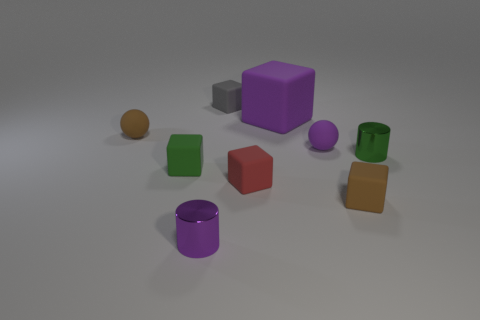Is there anything else that has the same size as the purple block?
Offer a very short reply. No. The large cube has what color?
Your answer should be compact. Purple. There is a brown object to the right of the purple metal object; how many purple objects are left of it?
Your answer should be very brief. 3. There is a green object that is to the left of the big object; is there a tiny brown rubber thing to the right of it?
Ensure brevity in your answer.  Yes. Are there any tiny purple balls in front of the large purple thing?
Keep it short and to the point. Yes. There is a tiny brown object that is in front of the small green cylinder; is it the same shape as the small red rubber object?
Ensure brevity in your answer.  Yes. How many other red things are the same shape as the large matte object?
Your answer should be compact. 1. Is there a small cube that has the same material as the gray object?
Your response must be concise. Yes. The purple thing in front of the shiny thing behind the purple metal thing is made of what material?
Your answer should be very brief. Metal. There is a cylinder that is on the right side of the tiny gray thing; how big is it?
Your answer should be compact. Small. 